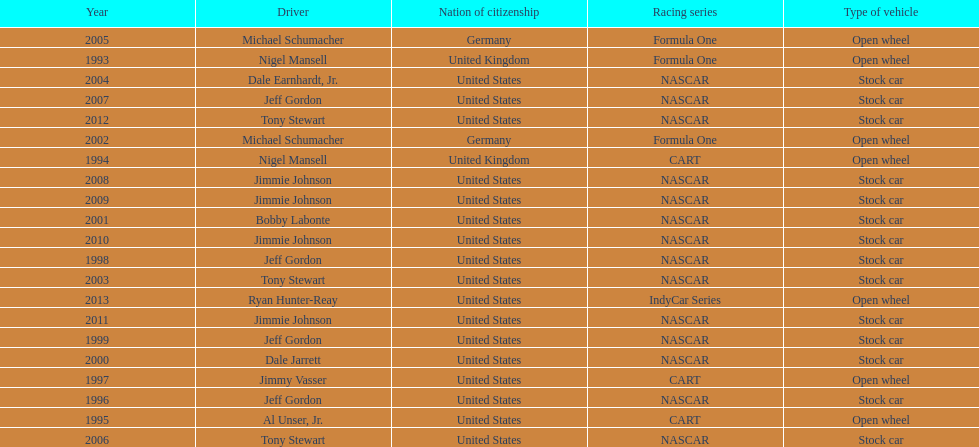Jimmy johnson won how many consecutive espy awards? 4. Can you give me this table as a dict? {'header': ['Year', 'Driver', 'Nation of citizenship', 'Racing series', 'Type of vehicle'], 'rows': [['2005', 'Michael Schumacher', 'Germany', 'Formula One', 'Open wheel'], ['1993', 'Nigel Mansell', 'United Kingdom', 'Formula One', 'Open wheel'], ['2004', 'Dale Earnhardt, Jr.', 'United States', 'NASCAR', 'Stock car'], ['2007', 'Jeff Gordon', 'United States', 'NASCAR', 'Stock car'], ['2012', 'Tony Stewart', 'United States', 'NASCAR', 'Stock car'], ['2002', 'Michael Schumacher', 'Germany', 'Formula One', 'Open wheel'], ['1994', 'Nigel Mansell', 'United Kingdom', 'CART', 'Open wheel'], ['2008', 'Jimmie Johnson', 'United States', 'NASCAR', 'Stock car'], ['2009', 'Jimmie Johnson', 'United States', 'NASCAR', 'Stock car'], ['2001', 'Bobby Labonte', 'United States', 'NASCAR', 'Stock car'], ['2010', 'Jimmie Johnson', 'United States', 'NASCAR', 'Stock car'], ['1998', 'Jeff Gordon', 'United States', 'NASCAR', 'Stock car'], ['2003', 'Tony Stewart', 'United States', 'NASCAR', 'Stock car'], ['2013', 'Ryan Hunter-Reay', 'United States', 'IndyCar Series', 'Open wheel'], ['2011', 'Jimmie Johnson', 'United States', 'NASCAR', 'Stock car'], ['1999', 'Jeff Gordon', 'United States', 'NASCAR', 'Stock car'], ['2000', 'Dale Jarrett', 'United States', 'NASCAR', 'Stock car'], ['1997', 'Jimmy Vasser', 'United States', 'CART', 'Open wheel'], ['1996', 'Jeff Gordon', 'United States', 'NASCAR', 'Stock car'], ['1995', 'Al Unser, Jr.', 'United States', 'CART', 'Open wheel'], ['2006', 'Tony Stewart', 'United States', 'NASCAR', 'Stock car']]} 